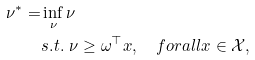Convert formula to latex. <formula><loc_0><loc_0><loc_500><loc_500>\nu ^ { * } = & \inf _ { \nu } \nu \\ & s . t . \ \nu \geq \omega ^ { \top } x , \quad f o r a l l x \in \mathcal { X } ,</formula> 